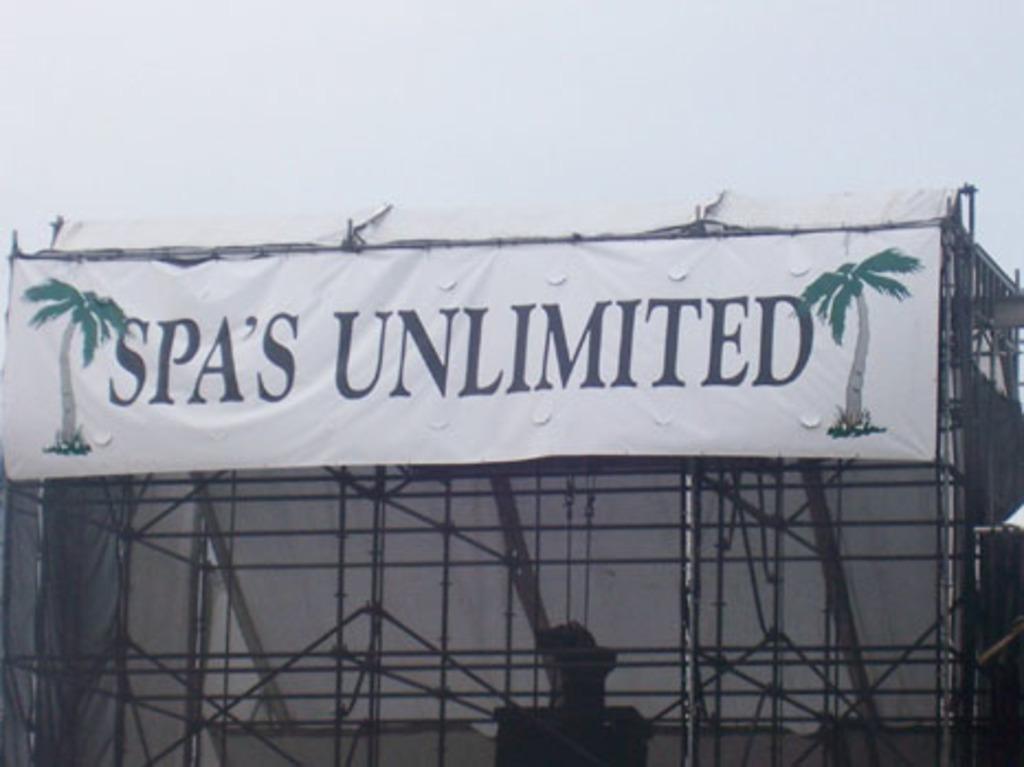What kind of tubs do they sell?
Ensure brevity in your answer.  Spas. 